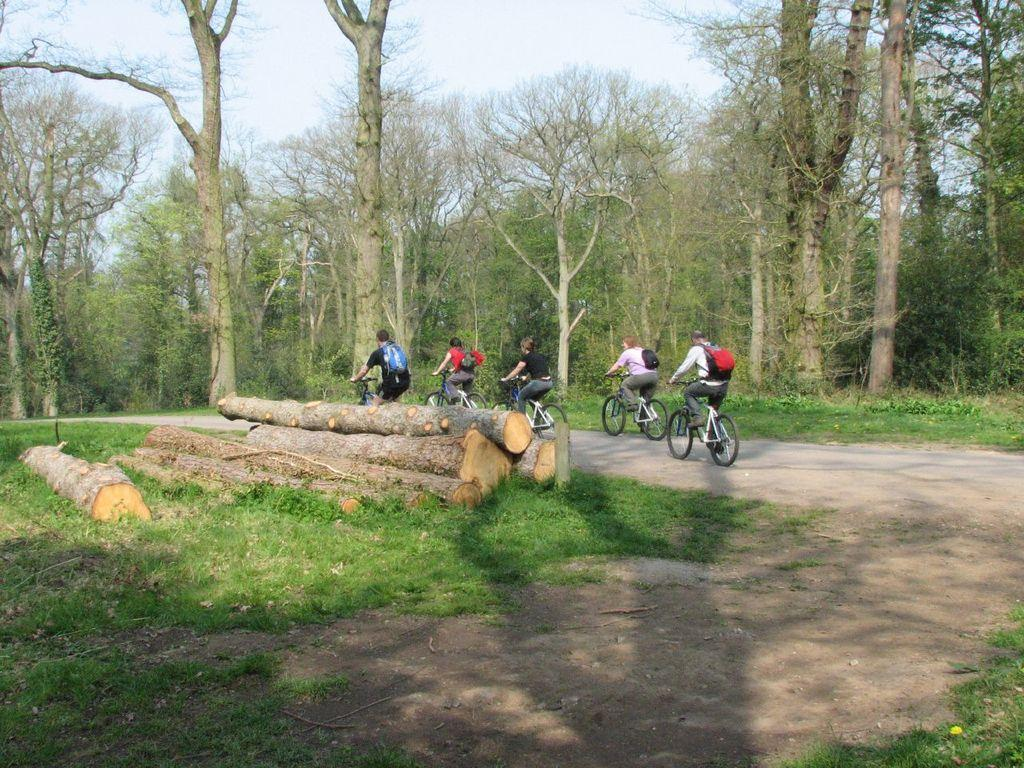What activity are the people in the image engaged in? The people in the image are cycling. What can be seen on the ground in the image? There are cut woods and grass visible in the image. What type of surface do the people appear to be cycling on? There is a path in the image, which is likely the surface they are cycling on. What type of vegetation is visible in the image? Trees are visible in the image. What is visible in the background of the image? The sky is visible in the image. Can you see a boat in the image? No, there is no boat present in the image. Is there a baby visible in the image? No, there is no baby present in the image. 